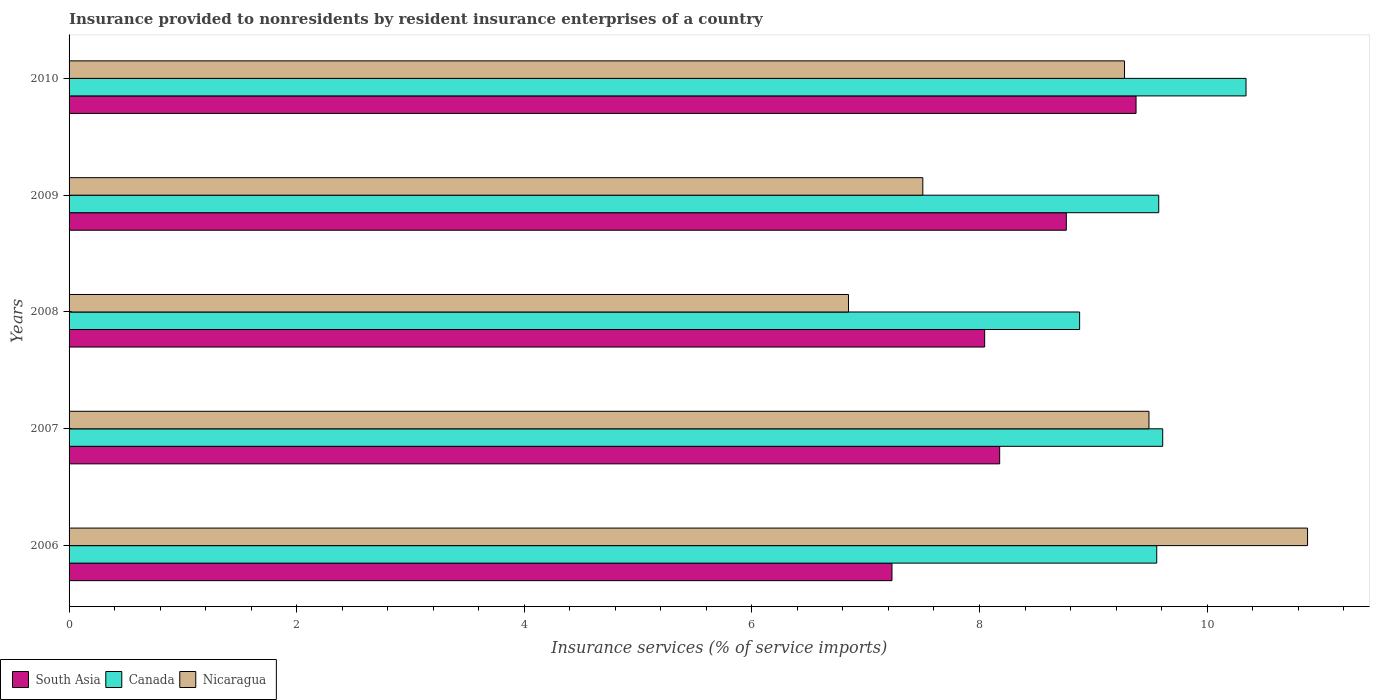Are the number of bars per tick equal to the number of legend labels?
Offer a very short reply. Yes. Are the number of bars on each tick of the Y-axis equal?
Your answer should be compact. Yes. How many bars are there on the 3rd tick from the top?
Make the answer very short. 3. How many bars are there on the 4th tick from the bottom?
Give a very brief answer. 3. In how many cases, is the number of bars for a given year not equal to the number of legend labels?
Give a very brief answer. 0. What is the insurance provided to nonresidents in Canada in 2006?
Your response must be concise. 9.56. Across all years, what is the maximum insurance provided to nonresidents in Nicaragua?
Give a very brief answer. 10.88. Across all years, what is the minimum insurance provided to nonresidents in Nicaragua?
Keep it short and to the point. 6.85. What is the total insurance provided to nonresidents in Canada in the graph?
Your response must be concise. 47.96. What is the difference between the insurance provided to nonresidents in Canada in 2007 and that in 2010?
Provide a short and direct response. -0.73. What is the difference between the insurance provided to nonresidents in Nicaragua in 2010 and the insurance provided to nonresidents in South Asia in 2009?
Ensure brevity in your answer.  0.51. What is the average insurance provided to nonresidents in Nicaragua per year?
Your response must be concise. 8.8. In the year 2006, what is the difference between the insurance provided to nonresidents in South Asia and insurance provided to nonresidents in Canada?
Your answer should be very brief. -2.33. In how many years, is the insurance provided to nonresidents in Nicaragua greater than 8.8 %?
Your answer should be very brief. 3. What is the ratio of the insurance provided to nonresidents in Nicaragua in 2009 to that in 2010?
Give a very brief answer. 0.81. Is the difference between the insurance provided to nonresidents in South Asia in 2008 and 2010 greater than the difference between the insurance provided to nonresidents in Canada in 2008 and 2010?
Make the answer very short. Yes. What is the difference between the highest and the second highest insurance provided to nonresidents in South Asia?
Offer a very short reply. 0.61. What is the difference between the highest and the lowest insurance provided to nonresidents in Nicaragua?
Your answer should be very brief. 4.03. Is the sum of the insurance provided to nonresidents in South Asia in 2008 and 2009 greater than the maximum insurance provided to nonresidents in Nicaragua across all years?
Provide a succinct answer. Yes. What does the 1st bar from the top in 2009 represents?
Your response must be concise. Nicaragua. What does the 3rd bar from the bottom in 2009 represents?
Your response must be concise. Nicaragua. Is it the case that in every year, the sum of the insurance provided to nonresidents in South Asia and insurance provided to nonresidents in Canada is greater than the insurance provided to nonresidents in Nicaragua?
Provide a succinct answer. Yes. Are all the bars in the graph horizontal?
Ensure brevity in your answer.  Yes. What is the difference between two consecutive major ticks on the X-axis?
Your response must be concise. 2. Does the graph contain any zero values?
Your answer should be very brief. No. Does the graph contain grids?
Provide a short and direct response. No. How many legend labels are there?
Your answer should be very brief. 3. How are the legend labels stacked?
Provide a succinct answer. Horizontal. What is the title of the graph?
Your response must be concise. Insurance provided to nonresidents by resident insurance enterprises of a country. Does "Australia" appear as one of the legend labels in the graph?
Offer a terse response. No. What is the label or title of the X-axis?
Make the answer very short. Insurance services (% of service imports). What is the Insurance services (% of service imports) in South Asia in 2006?
Your answer should be compact. 7.23. What is the Insurance services (% of service imports) of Canada in 2006?
Provide a succinct answer. 9.56. What is the Insurance services (% of service imports) in Nicaragua in 2006?
Your response must be concise. 10.88. What is the Insurance services (% of service imports) in South Asia in 2007?
Your answer should be very brief. 8.18. What is the Insurance services (% of service imports) of Canada in 2007?
Your answer should be compact. 9.61. What is the Insurance services (% of service imports) of Nicaragua in 2007?
Your answer should be compact. 9.49. What is the Insurance services (% of service imports) of South Asia in 2008?
Make the answer very short. 8.05. What is the Insurance services (% of service imports) in Canada in 2008?
Provide a succinct answer. 8.88. What is the Insurance services (% of service imports) of Nicaragua in 2008?
Your answer should be compact. 6.85. What is the Insurance services (% of service imports) in South Asia in 2009?
Provide a succinct answer. 8.76. What is the Insurance services (% of service imports) in Canada in 2009?
Provide a short and direct response. 9.58. What is the Insurance services (% of service imports) of Nicaragua in 2009?
Your response must be concise. 7.5. What is the Insurance services (% of service imports) in South Asia in 2010?
Offer a very short reply. 9.38. What is the Insurance services (% of service imports) in Canada in 2010?
Provide a succinct answer. 10.34. What is the Insurance services (% of service imports) of Nicaragua in 2010?
Your response must be concise. 9.27. Across all years, what is the maximum Insurance services (% of service imports) in South Asia?
Give a very brief answer. 9.38. Across all years, what is the maximum Insurance services (% of service imports) in Canada?
Your answer should be very brief. 10.34. Across all years, what is the maximum Insurance services (% of service imports) in Nicaragua?
Provide a succinct answer. 10.88. Across all years, what is the minimum Insurance services (% of service imports) in South Asia?
Your answer should be very brief. 7.23. Across all years, what is the minimum Insurance services (% of service imports) in Canada?
Make the answer very short. 8.88. Across all years, what is the minimum Insurance services (% of service imports) in Nicaragua?
Offer a very short reply. 6.85. What is the total Insurance services (% of service imports) of South Asia in the graph?
Keep it short and to the point. 41.59. What is the total Insurance services (% of service imports) in Canada in the graph?
Make the answer very short. 47.96. What is the total Insurance services (% of service imports) in Nicaragua in the graph?
Provide a short and direct response. 44. What is the difference between the Insurance services (% of service imports) in South Asia in 2006 and that in 2007?
Offer a terse response. -0.95. What is the difference between the Insurance services (% of service imports) of Canada in 2006 and that in 2007?
Offer a very short reply. -0.05. What is the difference between the Insurance services (% of service imports) of Nicaragua in 2006 and that in 2007?
Your answer should be compact. 1.39. What is the difference between the Insurance services (% of service imports) of South Asia in 2006 and that in 2008?
Provide a short and direct response. -0.81. What is the difference between the Insurance services (% of service imports) of Canada in 2006 and that in 2008?
Keep it short and to the point. 0.68. What is the difference between the Insurance services (% of service imports) of Nicaragua in 2006 and that in 2008?
Ensure brevity in your answer.  4.03. What is the difference between the Insurance services (% of service imports) of South Asia in 2006 and that in 2009?
Your response must be concise. -1.53. What is the difference between the Insurance services (% of service imports) of Canada in 2006 and that in 2009?
Your answer should be very brief. -0.02. What is the difference between the Insurance services (% of service imports) of Nicaragua in 2006 and that in 2009?
Offer a very short reply. 3.38. What is the difference between the Insurance services (% of service imports) in South Asia in 2006 and that in 2010?
Provide a short and direct response. -2.14. What is the difference between the Insurance services (% of service imports) of Canada in 2006 and that in 2010?
Give a very brief answer. -0.78. What is the difference between the Insurance services (% of service imports) of Nicaragua in 2006 and that in 2010?
Your answer should be very brief. 1.61. What is the difference between the Insurance services (% of service imports) of South Asia in 2007 and that in 2008?
Your answer should be very brief. 0.13. What is the difference between the Insurance services (% of service imports) of Canada in 2007 and that in 2008?
Ensure brevity in your answer.  0.73. What is the difference between the Insurance services (% of service imports) of Nicaragua in 2007 and that in 2008?
Provide a short and direct response. 2.64. What is the difference between the Insurance services (% of service imports) of South Asia in 2007 and that in 2009?
Keep it short and to the point. -0.59. What is the difference between the Insurance services (% of service imports) of Canada in 2007 and that in 2009?
Your answer should be very brief. 0.03. What is the difference between the Insurance services (% of service imports) in Nicaragua in 2007 and that in 2009?
Give a very brief answer. 1.99. What is the difference between the Insurance services (% of service imports) in South Asia in 2007 and that in 2010?
Provide a succinct answer. -1.2. What is the difference between the Insurance services (% of service imports) of Canada in 2007 and that in 2010?
Offer a terse response. -0.73. What is the difference between the Insurance services (% of service imports) of Nicaragua in 2007 and that in 2010?
Ensure brevity in your answer.  0.21. What is the difference between the Insurance services (% of service imports) in South Asia in 2008 and that in 2009?
Provide a succinct answer. -0.72. What is the difference between the Insurance services (% of service imports) of Canada in 2008 and that in 2009?
Provide a short and direct response. -0.7. What is the difference between the Insurance services (% of service imports) of Nicaragua in 2008 and that in 2009?
Ensure brevity in your answer.  -0.65. What is the difference between the Insurance services (% of service imports) of South Asia in 2008 and that in 2010?
Ensure brevity in your answer.  -1.33. What is the difference between the Insurance services (% of service imports) in Canada in 2008 and that in 2010?
Give a very brief answer. -1.46. What is the difference between the Insurance services (% of service imports) of Nicaragua in 2008 and that in 2010?
Your answer should be very brief. -2.43. What is the difference between the Insurance services (% of service imports) of South Asia in 2009 and that in 2010?
Offer a terse response. -0.61. What is the difference between the Insurance services (% of service imports) of Canada in 2009 and that in 2010?
Provide a succinct answer. -0.77. What is the difference between the Insurance services (% of service imports) in Nicaragua in 2009 and that in 2010?
Your answer should be very brief. -1.77. What is the difference between the Insurance services (% of service imports) in South Asia in 2006 and the Insurance services (% of service imports) in Canada in 2007?
Ensure brevity in your answer.  -2.38. What is the difference between the Insurance services (% of service imports) in South Asia in 2006 and the Insurance services (% of service imports) in Nicaragua in 2007?
Provide a short and direct response. -2.26. What is the difference between the Insurance services (% of service imports) of Canada in 2006 and the Insurance services (% of service imports) of Nicaragua in 2007?
Your response must be concise. 0.07. What is the difference between the Insurance services (% of service imports) of South Asia in 2006 and the Insurance services (% of service imports) of Canada in 2008?
Your answer should be compact. -1.65. What is the difference between the Insurance services (% of service imports) of South Asia in 2006 and the Insurance services (% of service imports) of Nicaragua in 2008?
Your response must be concise. 0.38. What is the difference between the Insurance services (% of service imports) of Canada in 2006 and the Insurance services (% of service imports) of Nicaragua in 2008?
Ensure brevity in your answer.  2.71. What is the difference between the Insurance services (% of service imports) of South Asia in 2006 and the Insurance services (% of service imports) of Canada in 2009?
Offer a very short reply. -2.34. What is the difference between the Insurance services (% of service imports) in South Asia in 2006 and the Insurance services (% of service imports) in Nicaragua in 2009?
Your answer should be very brief. -0.27. What is the difference between the Insurance services (% of service imports) in Canada in 2006 and the Insurance services (% of service imports) in Nicaragua in 2009?
Your answer should be compact. 2.06. What is the difference between the Insurance services (% of service imports) in South Asia in 2006 and the Insurance services (% of service imports) in Canada in 2010?
Keep it short and to the point. -3.11. What is the difference between the Insurance services (% of service imports) in South Asia in 2006 and the Insurance services (% of service imports) in Nicaragua in 2010?
Provide a short and direct response. -2.04. What is the difference between the Insurance services (% of service imports) in Canada in 2006 and the Insurance services (% of service imports) in Nicaragua in 2010?
Make the answer very short. 0.28. What is the difference between the Insurance services (% of service imports) in South Asia in 2007 and the Insurance services (% of service imports) in Canada in 2008?
Give a very brief answer. -0.7. What is the difference between the Insurance services (% of service imports) in South Asia in 2007 and the Insurance services (% of service imports) in Nicaragua in 2008?
Keep it short and to the point. 1.33. What is the difference between the Insurance services (% of service imports) of Canada in 2007 and the Insurance services (% of service imports) of Nicaragua in 2008?
Your answer should be compact. 2.76. What is the difference between the Insurance services (% of service imports) of South Asia in 2007 and the Insurance services (% of service imports) of Canada in 2009?
Your answer should be compact. -1.4. What is the difference between the Insurance services (% of service imports) in South Asia in 2007 and the Insurance services (% of service imports) in Nicaragua in 2009?
Offer a very short reply. 0.68. What is the difference between the Insurance services (% of service imports) of Canada in 2007 and the Insurance services (% of service imports) of Nicaragua in 2009?
Provide a short and direct response. 2.11. What is the difference between the Insurance services (% of service imports) in South Asia in 2007 and the Insurance services (% of service imports) in Canada in 2010?
Offer a very short reply. -2.16. What is the difference between the Insurance services (% of service imports) in South Asia in 2007 and the Insurance services (% of service imports) in Nicaragua in 2010?
Provide a short and direct response. -1.1. What is the difference between the Insurance services (% of service imports) of Canada in 2007 and the Insurance services (% of service imports) of Nicaragua in 2010?
Provide a succinct answer. 0.34. What is the difference between the Insurance services (% of service imports) of South Asia in 2008 and the Insurance services (% of service imports) of Canada in 2009?
Make the answer very short. -1.53. What is the difference between the Insurance services (% of service imports) of South Asia in 2008 and the Insurance services (% of service imports) of Nicaragua in 2009?
Your answer should be compact. 0.54. What is the difference between the Insurance services (% of service imports) in Canada in 2008 and the Insurance services (% of service imports) in Nicaragua in 2009?
Keep it short and to the point. 1.38. What is the difference between the Insurance services (% of service imports) of South Asia in 2008 and the Insurance services (% of service imports) of Canada in 2010?
Give a very brief answer. -2.3. What is the difference between the Insurance services (% of service imports) of South Asia in 2008 and the Insurance services (% of service imports) of Nicaragua in 2010?
Make the answer very short. -1.23. What is the difference between the Insurance services (% of service imports) in Canada in 2008 and the Insurance services (% of service imports) in Nicaragua in 2010?
Keep it short and to the point. -0.39. What is the difference between the Insurance services (% of service imports) of South Asia in 2009 and the Insurance services (% of service imports) of Canada in 2010?
Your answer should be very brief. -1.58. What is the difference between the Insurance services (% of service imports) in South Asia in 2009 and the Insurance services (% of service imports) in Nicaragua in 2010?
Your answer should be very brief. -0.51. What is the difference between the Insurance services (% of service imports) in Canada in 2009 and the Insurance services (% of service imports) in Nicaragua in 2010?
Keep it short and to the point. 0.3. What is the average Insurance services (% of service imports) of South Asia per year?
Your response must be concise. 8.32. What is the average Insurance services (% of service imports) in Canada per year?
Ensure brevity in your answer.  9.59. What is the average Insurance services (% of service imports) in Nicaragua per year?
Offer a terse response. 8.8. In the year 2006, what is the difference between the Insurance services (% of service imports) of South Asia and Insurance services (% of service imports) of Canada?
Your answer should be compact. -2.33. In the year 2006, what is the difference between the Insurance services (% of service imports) in South Asia and Insurance services (% of service imports) in Nicaragua?
Keep it short and to the point. -3.65. In the year 2006, what is the difference between the Insurance services (% of service imports) of Canada and Insurance services (% of service imports) of Nicaragua?
Make the answer very short. -1.33. In the year 2007, what is the difference between the Insurance services (% of service imports) of South Asia and Insurance services (% of service imports) of Canada?
Provide a short and direct response. -1.43. In the year 2007, what is the difference between the Insurance services (% of service imports) in South Asia and Insurance services (% of service imports) in Nicaragua?
Ensure brevity in your answer.  -1.31. In the year 2007, what is the difference between the Insurance services (% of service imports) of Canada and Insurance services (% of service imports) of Nicaragua?
Ensure brevity in your answer.  0.12. In the year 2008, what is the difference between the Insurance services (% of service imports) in South Asia and Insurance services (% of service imports) in Canada?
Your answer should be compact. -0.83. In the year 2008, what is the difference between the Insurance services (% of service imports) of South Asia and Insurance services (% of service imports) of Nicaragua?
Offer a very short reply. 1.2. In the year 2008, what is the difference between the Insurance services (% of service imports) in Canada and Insurance services (% of service imports) in Nicaragua?
Offer a terse response. 2.03. In the year 2009, what is the difference between the Insurance services (% of service imports) in South Asia and Insurance services (% of service imports) in Canada?
Ensure brevity in your answer.  -0.81. In the year 2009, what is the difference between the Insurance services (% of service imports) of South Asia and Insurance services (% of service imports) of Nicaragua?
Make the answer very short. 1.26. In the year 2009, what is the difference between the Insurance services (% of service imports) in Canada and Insurance services (% of service imports) in Nicaragua?
Ensure brevity in your answer.  2.07. In the year 2010, what is the difference between the Insurance services (% of service imports) in South Asia and Insurance services (% of service imports) in Canada?
Ensure brevity in your answer.  -0.97. In the year 2010, what is the difference between the Insurance services (% of service imports) in South Asia and Insurance services (% of service imports) in Nicaragua?
Your answer should be compact. 0.1. In the year 2010, what is the difference between the Insurance services (% of service imports) of Canada and Insurance services (% of service imports) of Nicaragua?
Provide a succinct answer. 1.07. What is the ratio of the Insurance services (% of service imports) of South Asia in 2006 to that in 2007?
Your answer should be very brief. 0.88. What is the ratio of the Insurance services (% of service imports) in Nicaragua in 2006 to that in 2007?
Provide a succinct answer. 1.15. What is the ratio of the Insurance services (% of service imports) in South Asia in 2006 to that in 2008?
Provide a succinct answer. 0.9. What is the ratio of the Insurance services (% of service imports) of Canada in 2006 to that in 2008?
Give a very brief answer. 1.08. What is the ratio of the Insurance services (% of service imports) in Nicaragua in 2006 to that in 2008?
Your answer should be very brief. 1.59. What is the ratio of the Insurance services (% of service imports) in South Asia in 2006 to that in 2009?
Make the answer very short. 0.83. What is the ratio of the Insurance services (% of service imports) of Canada in 2006 to that in 2009?
Your answer should be compact. 1. What is the ratio of the Insurance services (% of service imports) of Nicaragua in 2006 to that in 2009?
Your answer should be very brief. 1.45. What is the ratio of the Insurance services (% of service imports) in South Asia in 2006 to that in 2010?
Your answer should be very brief. 0.77. What is the ratio of the Insurance services (% of service imports) of Canada in 2006 to that in 2010?
Offer a terse response. 0.92. What is the ratio of the Insurance services (% of service imports) in Nicaragua in 2006 to that in 2010?
Give a very brief answer. 1.17. What is the ratio of the Insurance services (% of service imports) in South Asia in 2007 to that in 2008?
Your answer should be very brief. 1.02. What is the ratio of the Insurance services (% of service imports) of Canada in 2007 to that in 2008?
Ensure brevity in your answer.  1.08. What is the ratio of the Insurance services (% of service imports) of Nicaragua in 2007 to that in 2008?
Your response must be concise. 1.39. What is the ratio of the Insurance services (% of service imports) of South Asia in 2007 to that in 2009?
Your response must be concise. 0.93. What is the ratio of the Insurance services (% of service imports) in Nicaragua in 2007 to that in 2009?
Provide a short and direct response. 1.26. What is the ratio of the Insurance services (% of service imports) in South Asia in 2007 to that in 2010?
Your answer should be compact. 0.87. What is the ratio of the Insurance services (% of service imports) in Canada in 2007 to that in 2010?
Provide a short and direct response. 0.93. What is the ratio of the Insurance services (% of service imports) of Nicaragua in 2007 to that in 2010?
Offer a very short reply. 1.02. What is the ratio of the Insurance services (% of service imports) in South Asia in 2008 to that in 2009?
Provide a short and direct response. 0.92. What is the ratio of the Insurance services (% of service imports) in Canada in 2008 to that in 2009?
Your answer should be compact. 0.93. What is the ratio of the Insurance services (% of service imports) in Nicaragua in 2008 to that in 2009?
Provide a short and direct response. 0.91. What is the ratio of the Insurance services (% of service imports) in South Asia in 2008 to that in 2010?
Offer a very short reply. 0.86. What is the ratio of the Insurance services (% of service imports) of Canada in 2008 to that in 2010?
Offer a terse response. 0.86. What is the ratio of the Insurance services (% of service imports) of Nicaragua in 2008 to that in 2010?
Offer a terse response. 0.74. What is the ratio of the Insurance services (% of service imports) of South Asia in 2009 to that in 2010?
Make the answer very short. 0.93. What is the ratio of the Insurance services (% of service imports) in Canada in 2009 to that in 2010?
Offer a terse response. 0.93. What is the ratio of the Insurance services (% of service imports) of Nicaragua in 2009 to that in 2010?
Your answer should be compact. 0.81. What is the difference between the highest and the second highest Insurance services (% of service imports) in South Asia?
Ensure brevity in your answer.  0.61. What is the difference between the highest and the second highest Insurance services (% of service imports) in Canada?
Offer a very short reply. 0.73. What is the difference between the highest and the second highest Insurance services (% of service imports) of Nicaragua?
Your answer should be very brief. 1.39. What is the difference between the highest and the lowest Insurance services (% of service imports) in South Asia?
Offer a very short reply. 2.14. What is the difference between the highest and the lowest Insurance services (% of service imports) in Canada?
Provide a succinct answer. 1.46. What is the difference between the highest and the lowest Insurance services (% of service imports) of Nicaragua?
Your answer should be compact. 4.03. 